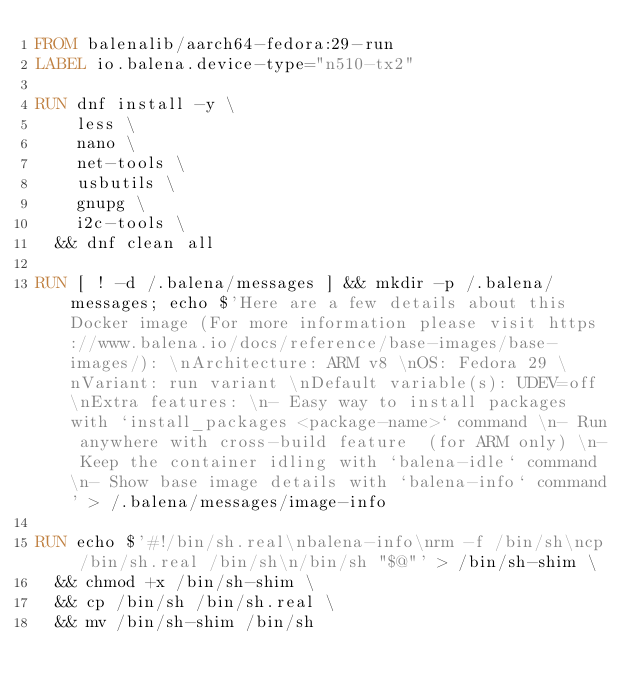Convert code to text. <code><loc_0><loc_0><loc_500><loc_500><_Dockerfile_>FROM balenalib/aarch64-fedora:29-run
LABEL io.balena.device-type="n510-tx2"

RUN dnf install -y \
		less \
		nano \
		net-tools \
		usbutils \
		gnupg \
		i2c-tools \
	&& dnf clean all

RUN [ ! -d /.balena/messages ] && mkdir -p /.balena/messages; echo $'Here are a few details about this Docker image (For more information please visit https://www.balena.io/docs/reference/base-images/base-images/): \nArchitecture: ARM v8 \nOS: Fedora 29 \nVariant: run variant \nDefault variable(s): UDEV=off \nExtra features: \n- Easy way to install packages with `install_packages <package-name>` command \n- Run anywhere with cross-build feature  (for ARM only) \n- Keep the container idling with `balena-idle` command \n- Show base image details with `balena-info` command' > /.balena/messages/image-info

RUN echo $'#!/bin/sh.real\nbalena-info\nrm -f /bin/sh\ncp /bin/sh.real /bin/sh\n/bin/sh "$@"' > /bin/sh-shim \
	&& chmod +x /bin/sh-shim \
	&& cp /bin/sh /bin/sh.real \
	&& mv /bin/sh-shim /bin/sh</code> 